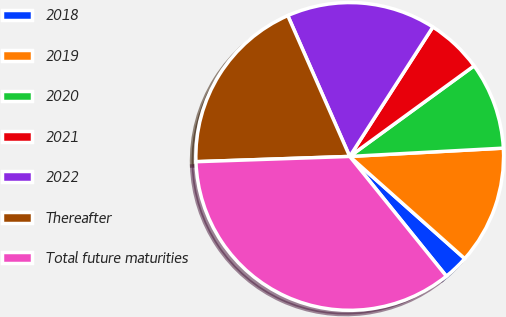Convert chart. <chart><loc_0><loc_0><loc_500><loc_500><pie_chart><fcel>2018<fcel>2019<fcel>2020<fcel>2021<fcel>2022<fcel>Thereafter<fcel>Total future maturities<nl><fcel>2.63%<fcel>12.42%<fcel>9.16%<fcel>5.89%<fcel>15.68%<fcel>18.95%<fcel>35.26%<nl></chart> 